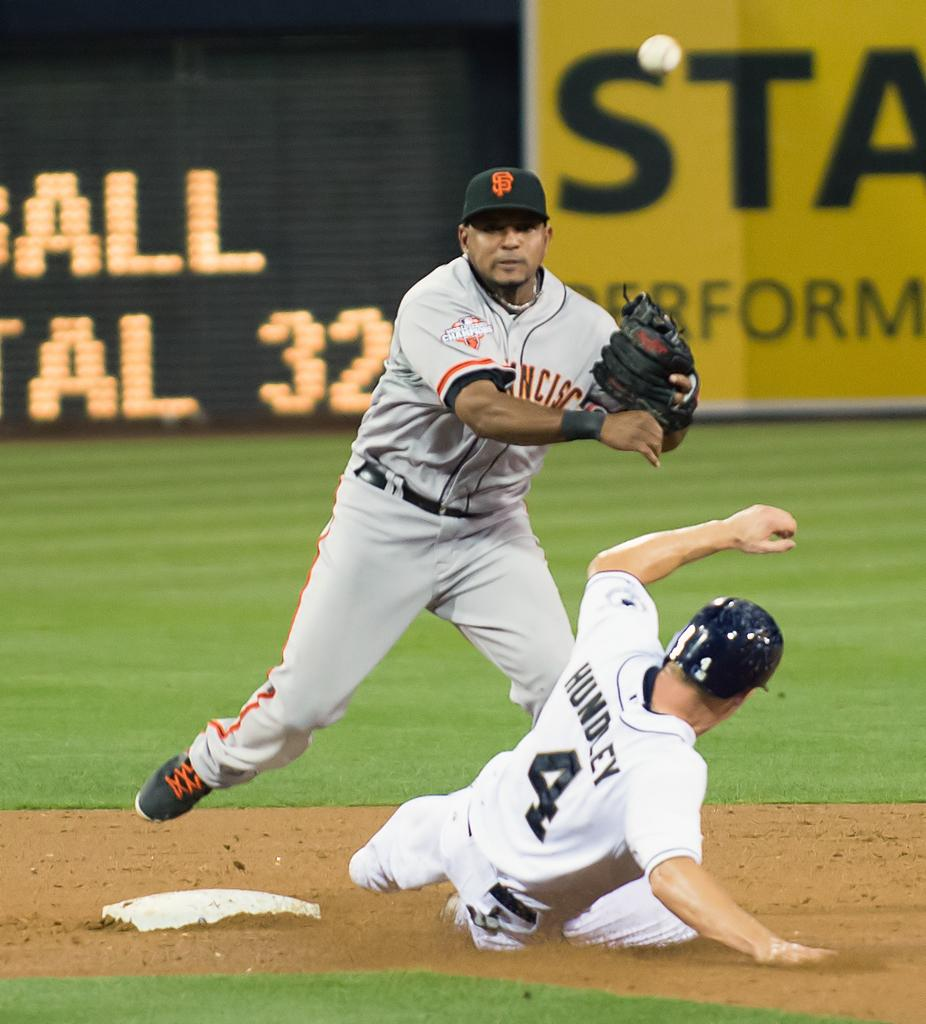<image>
Describe the image concisely. Hundley who wears number 4 slides into second place while a San Francisco defender tries to tag him out. 